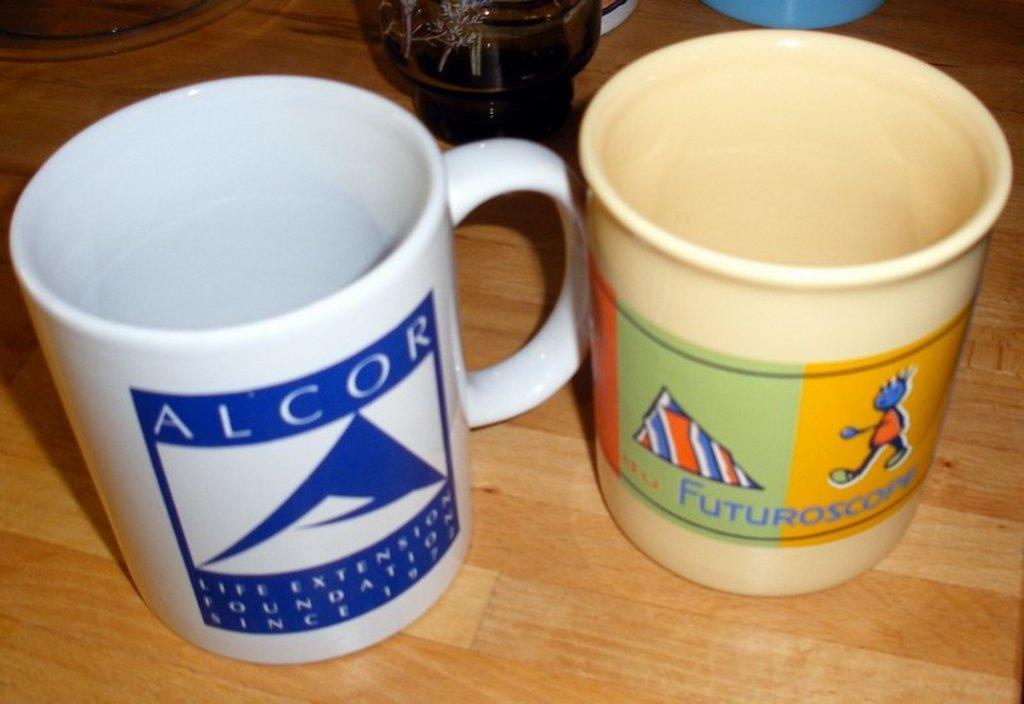Please provide a concise description of this image. In this image there are cups on a wooden table. There are logos, text and pictures on the cups. 